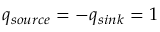Convert formula to latex. <formula><loc_0><loc_0><loc_500><loc_500>q _ { s o u r c e } = - q _ { \sin k } = 1</formula> 